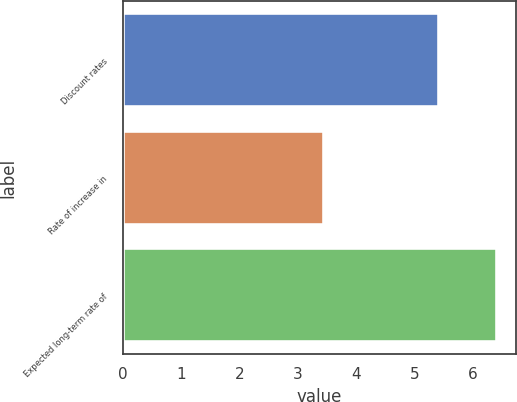<chart> <loc_0><loc_0><loc_500><loc_500><bar_chart><fcel>Discount rates<fcel>Rate of increase in<fcel>Expected long-term rate of<nl><fcel>5.42<fcel>3.45<fcel>6.42<nl></chart> 